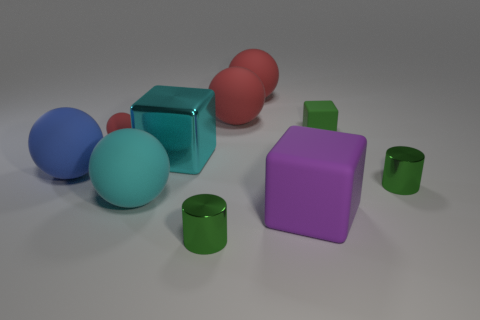Subtract all purple cylinders. How many red spheres are left? 3 Subtract all blue spheres. How many spheres are left? 4 Subtract all purple spheres. Subtract all gray cylinders. How many spheres are left? 5 Subtract all cylinders. How many objects are left? 8 Add 6 purple matte things. How many purple matte things are left? 7 Add 1 tiny green cubes. How many tiny green cubes exist? 2 Subtract 1 cyan spheres. How many objects are left? 9 Subtract all big green metallic cubes. Subtract all large blue balls. How many objects are left? 9 